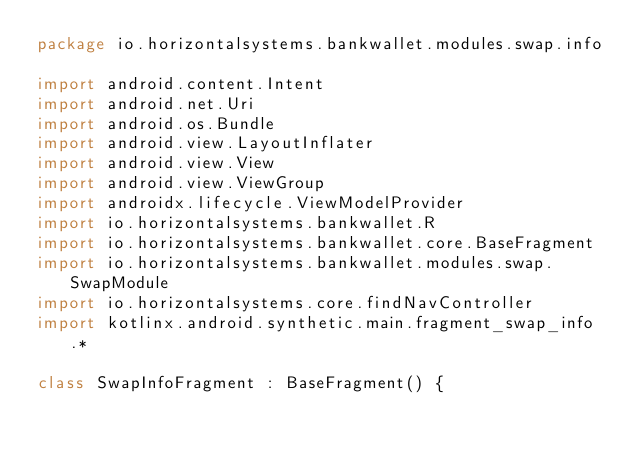Convert code to text. <code><loc_0><loc_0><loc_500><loc_500><_Kotlin_>package io.horizontalsystems.bankwallet.modules.swap.info

import android.content.Intent
import android.net.Uri
import android.os.Bundle
import android.view.LayoutInflater
import android.view.View
import android.view.ViewGroup
import androidx.lifecycle.ViewModelProvider
import io.horizontalsystems.bankwallet.R
import io.horizontalsystems.bankwallet.core.BaseFragment
import io.horizontalsystems.bankwallet.modules.swap.SwapModule
import io.horizontalsystems.core.findNavController
import kotlinx.android.synthetic.main.fragment_swap_info.*

class SwapInfoFragment : BaseFragment() {
</code> 